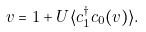Convert formula to latex. <formula><loc_0><loc_0><loc_500><loc_500>v = 1 + U \langle c _ { 1 } ^ { \dagger } c _ { 0 } ( v ) \rangle .</formula> 